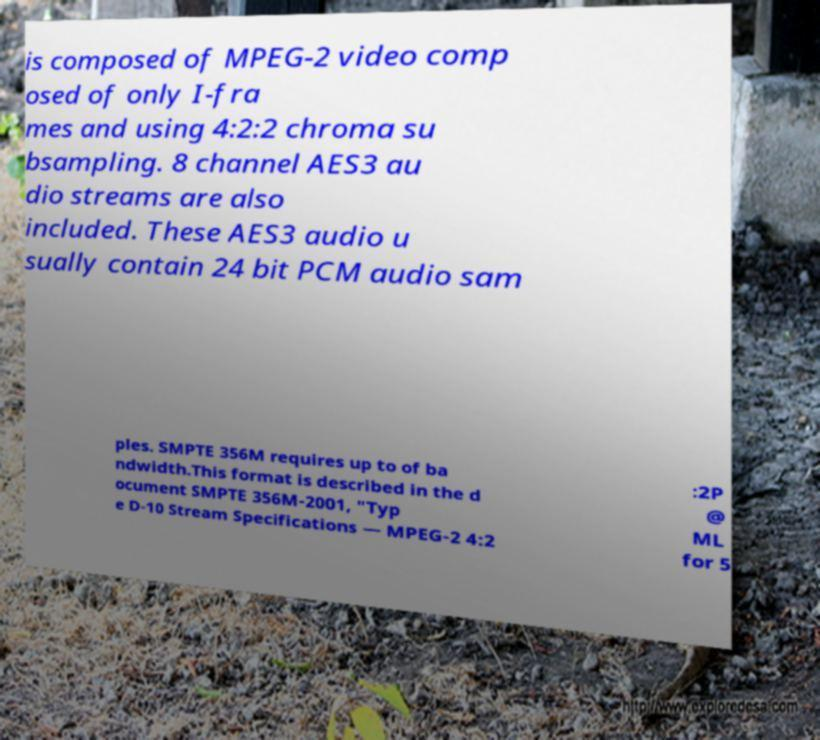Please read and relay the text visible in this image. What does it say? is composed of MPEG-2 video comp osed of only I-fra mes and using 4:2:2 chroma su bsampling. 8 channel AES3 au dio streams are also included. These AES3 audio u sually contain 24 bit PCM audio sam ples. SMPTE 356M requires up to of ba ndwidth.This format is described in the d ocument SMPTE 356M-2001, "Typ e D-10 Stream Specifications — MPEG-2 4:2 :2P @ ML for 5 